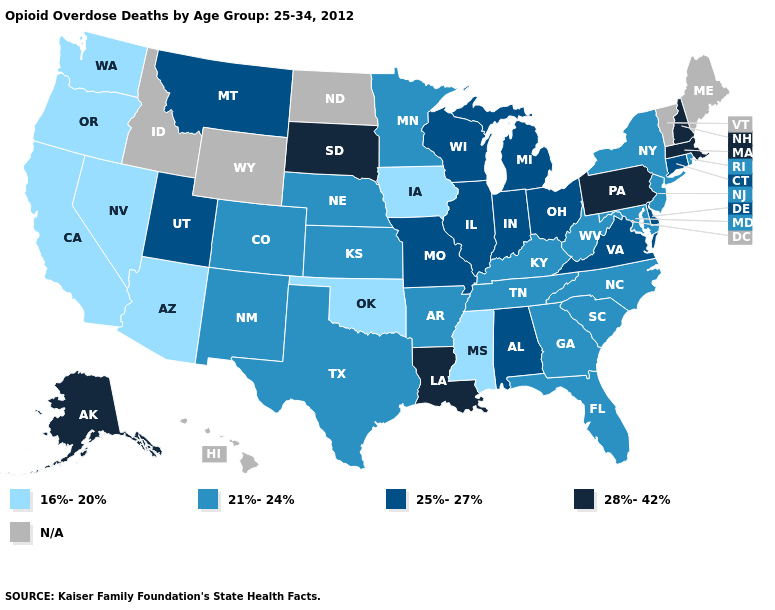Among the states that border Arizona , does California have the lowest value?
Give a very brief answer. Yes. What is the value of Maine?
Answer briefly. N/A. Does Alaska have the highest value in the West?
Give a very brief answer. Yes. What is the value of South Carolina?
Write a very short answer. 21%-24%. Name the states that have a value in the range 16%-20%?
Answer briefly. Arizona, California, Iowa, Mississippi, Nevada, Oklahoma, Oregon, Washington. Name the states that have a value in the range 25%-27%?
Quick response, please. Alabama, Connecticut, Delaware, Illinois, Indiana, Michigan, Missouri, Montana, Ohio, Utah, Virginia, Wisconsin. Which states have the lowest value in the Northeast?
Answer briefly. New Jersey, New York, Rhode Island. Name the states that have a value in the range 21%-24%?
Concise answer only. Arkansas, Colorado, Florida, Georgia, Kansas, Kentucky, Maryland, Minnesota, Nebraska, New Jersey, New Mexico, New York, North Carolina, Rhode Island, South Carolina, Tennessee, Texas, West Virginia. What is the value of Pennsylvania?
Write a very short answer. 28%-42%. What is the value of Connecticut?
Short answer required. 25%-27%. What is the value of California?
Answer briefly. 16%-20%. Does Rhode Island have the highest value in the Northeast?
Write a very short answer. No. What is the highest value in the USA?
Answer briefly. 28%-42%. What is the value of Michigan?
Answer briefly. 25%-27%. What is the highest value in states that border Colorado?
Short answer required. 25%-27%. 